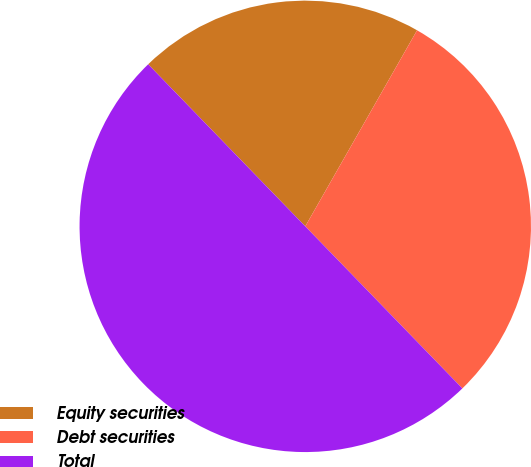Convert chart. <chart><loc_0><loc_0><loc_500><loc_500><pie_chart><fcel>Equity securities<fcel>Debt securities<fcel>Total<nl><fcel>20.5%<fcel>29.5%<fcel>50.0%<nl></chart> 